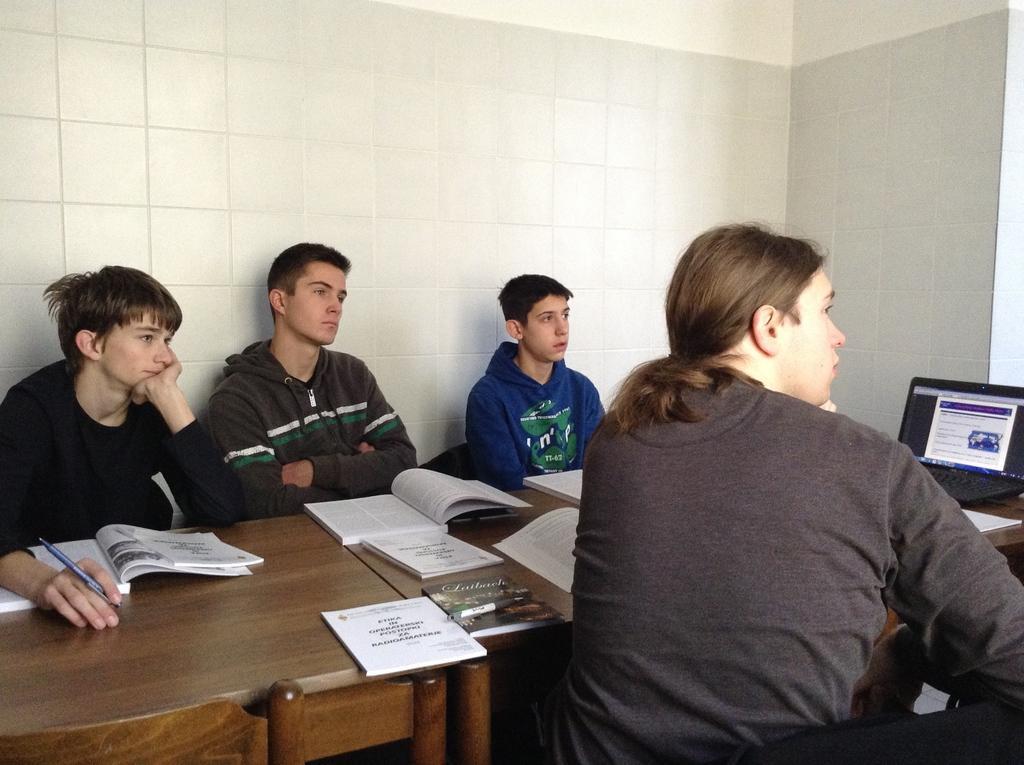How would you summarize this image in a sentence or two? there is a room in which people are sitting in the chairs and having books in their hands which are present on the table,there is a laptop on the table. 